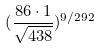<formula> <loc_0><loc_0><loc_500><loc_500>( \frac { 8 6 \cdot 1 } { \sqrt { 4 3 8 } } ) ^ { 9 / 2 9 2 }</formula> 